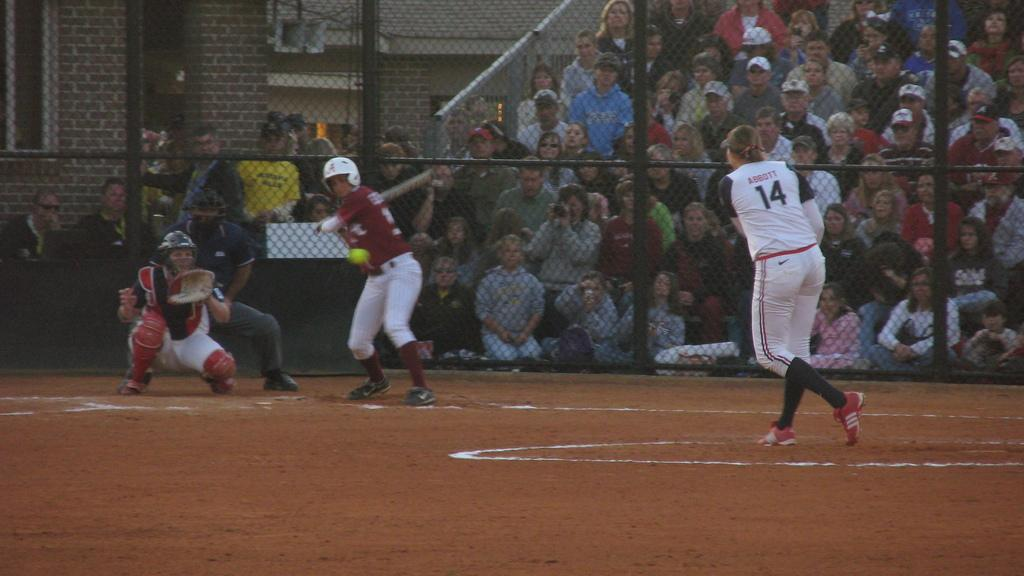Provide a one-sentence caption for the provided image. The pitcher, who is number 14, has just thrown the ball to the batter. 